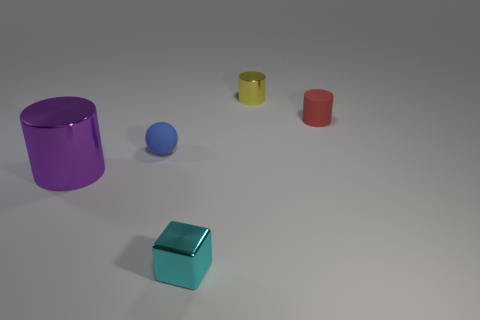How many things are both to the left of the yellow shiny thing and right of the purple metal thing?
Ensure brevity in your answer.  2. How many other objects are there of the same material as the small cyan block?
Your response must be concise. 2. There is a sphere that is on the left side of the tiny metal object that is behind the tiny cyan shiny cube; what color is it?
Keep it short and to the point. Blue. Is the color of the metallic cylinder right of the large purple shiny cylinder the same as the tiny sphere?
Make the answer very short. No. Does the yellow metal object have the same size as the blue matte sphere?
Ensure brevity in your answer.  Yes. The red rubber object that is the same size as the yellow metallic cylinder is what shape?
Provide a short and direct response. Cylinder. Does the thing right of the yellow metal thing have the same size as the small yellow metallic cylinder?
Offer a very short reply. Yes. There is a cyan block that is the same size as the yellow shiny object; what is its material?
Keep it short and to the point. Metal. There is a small metal thing in front of the cylinder that is left of the block; is there a big purple cylinder that is in front of it?
Ensure brevity in your answer.  No. Is there anything else that has the same shape as the small cyan thing?
Provide a succinct answer. No. 